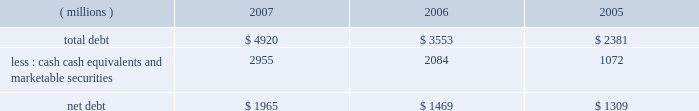New accounting pronouncements information regarding new accounting pronouncements is included in note 1 to the consolidated financial statements .
Financial condition and liquidity the company generates significant ongoing cash flow .
Increases in long-term debt have been used , in part , to fund share repurchase activities and acquisitions .
On november 15 , 2007 , 3m ( safety , security and protection services business ) announced that it had entered into a definitive agreement for 3m 2019s acquisition of 100 percent of the outstanding shares of aearo holding corp .
E83a a global leader in the personal protection industry that manufactures and markets personal protection and energy absorbing products e83a for approximately $ 1.2 billion .
The sale is expected to close towards the end of the first quarter of 2008 .
At december 31 .
Cash , cash equivalents and marketable securities at december 31 , 2007 totaled approximately $ 3 billion , helped by strong cash flow generation and by the timing of debt issuances .
At december 31 , 2006 , cash balances were higher due to the significant pharmaceuticals sales proceeds received in december 2006 .
3m believes its ongoing cash flows provide ample cash to fund expected investments and capital expenditures .
The company has sufficient access to capital markets to meet currently anticipated growth and acquisition investment funding needs .
The company does not utilize derivative instruments linked to the company 2019s stock .
However , the company does have contingently convertible debt that , if conditions for conversion are met , is convertible into shares of 3m common stock ( refer to note 10 in this document ) .
The company 2019s financial condition and liquidity are strong .
Various assets and liabilities , including cash and short-term debt , can fluctuate significantly from month to month depending on short-term liquidity needs .
Working capital ( defined as current assets minus current liabilities ) totaled $ 4.476 billion at december 31 , 2007 , compared with $ 1.623 billion at december 31 , 2006 .
Working capital was higher primarily due to increases in cash and cash equivalents , short-term marketable securities , receivables and inventories and decreases in short-term debt and accrued income taxes .
The company 2019s liquidity remains strong , with cash , cash equivalents and marketable securities at december 31 , 2007 totaling approximately $ 3 billion .
Primary short-term liquidity needs are provided through u.s .
Commercial paper and euro commercial paper issuances .
As of december 31 , 2007 , outstanding total commercial paper issued totaled $ 349 million and averaged $ 1.249 billion during 2007 .
The company believes it unlikely that its access to the commercial paper market will be restricted .
In june 2007 , the company established a medium-term notes program through which up to $ 3 billion of medium-term notes may be offered , with remaining shelf borrowing capacity of $ 2.5 billion as of december 31 , 2007 .
On april 30 , 2007 , the company replaced its $ 565-million credit facility with a new $ 1.5-billion five-year credit facility , which has provisions for the company to request an increase of the facility up to $ 2 billion ( at the lenders 2019 discretion ) , and providing for up to $ 150 million in letters of credit .
As of december 31 , 2007 , there are $ 110 million in letters of credit drawn against the facility .
At december 31 , 2007 , available short-term committed lines of credit internationally totaled approximately $ 67 million , of which $ 13 million was utilized .
Debt covenants do not restrict the payment of dividends .
The company has a "well-known seasoned issuer" shelf registration statement , effective february 24 , 2006 , to register an indeterminate amount of debt or equity securities for future sales .
The company intends to use the proceeds from future securities sales off this shelf for general corporate purposes .
At december 31 , 2007 , certain debt agreements ( $ 350 million of dealer remarketable securities and $ 87 million of esop debt ) had ratings triggers ( bbb-/baa3 or lower ) that would require repayment of debt .
The company has an aa credit rating , with a stable outlook , from standard & poor 2019s and an aa1 credit rating , with a negative outlook , from moody 2019s investors service .
In addition , under the $ 1.5-billion five-year credit facility agreement , 3m is required to maintain its ebitda to interest ratio as of the end of each fiscal quarter at not less than 3.0 to 1 .
This is calculated ( as defined in the agreement ) as the ratio of consolidated total ebitda for the four consecutive quarters then ended to total interest expense on all funded debt for the same period .
At december 31 , 2007 , this ratio was approximately 35 to 1. .
In 2007 what was the ratio of the total debt to cash cash equivalents and marketable securities? 
Rationale: for every $ 1 of cash cash equivalents and marketable securities there was $ 1.66 of debt in 2007
Computations: (4920 / 2955)
Answer: 1.66497. 